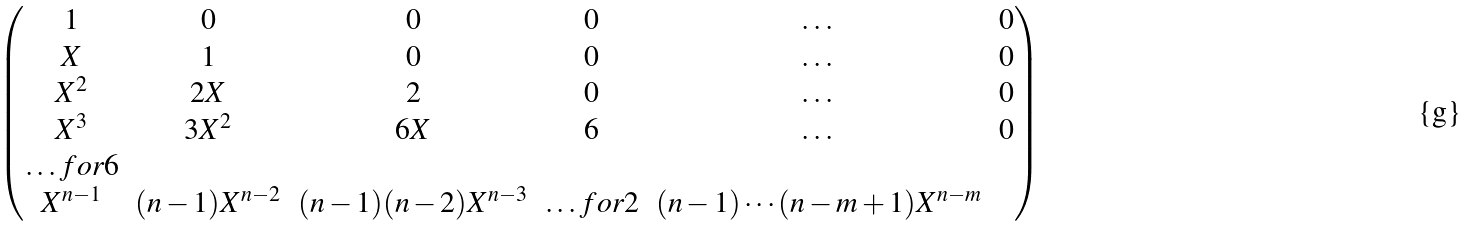<formula> <loc_0><loc_0><loc_500><loc_500>\begin{pmatrix} 1 & 0 & 0 & 0 & \dots & 0 \\ X & 1 & 0 & 0 & \dots & 0 \\ X ^ { 2 } & 2 X & 2 & 0 & \dots & 0 \\ X ^ { 3 } & 3 X ^ { 2 } & 6 X & 6 & \dots & 0 \\ \hdots f o r 6 \\ X ^ { n - 1 } & ( n - 1 ) X ^ { n - 2 } & ( n - 1 ) ( n - 2 ) X ^ { n - 3 } & \hdots f o r 2 & ( n - 1 ) \cdots ( n - m + 1 ) X ^ { n - m } \end{pmatrix}</formula> 